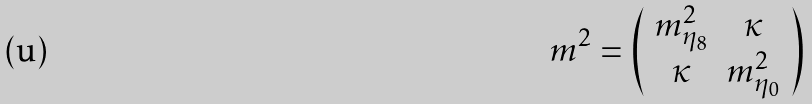Convert formula to latex. <formula><loc_0><loc_0><loc_500><loc_500>m ^ { 2 } = \left ( \begin{array} { c c } m _ { \eta _ { 8 } } ^ { 2 } & \kappa \\ \kappa & m _ { \eta _ { 0 } } ^ { 2 } \\ \end{array} \right )</formula> 